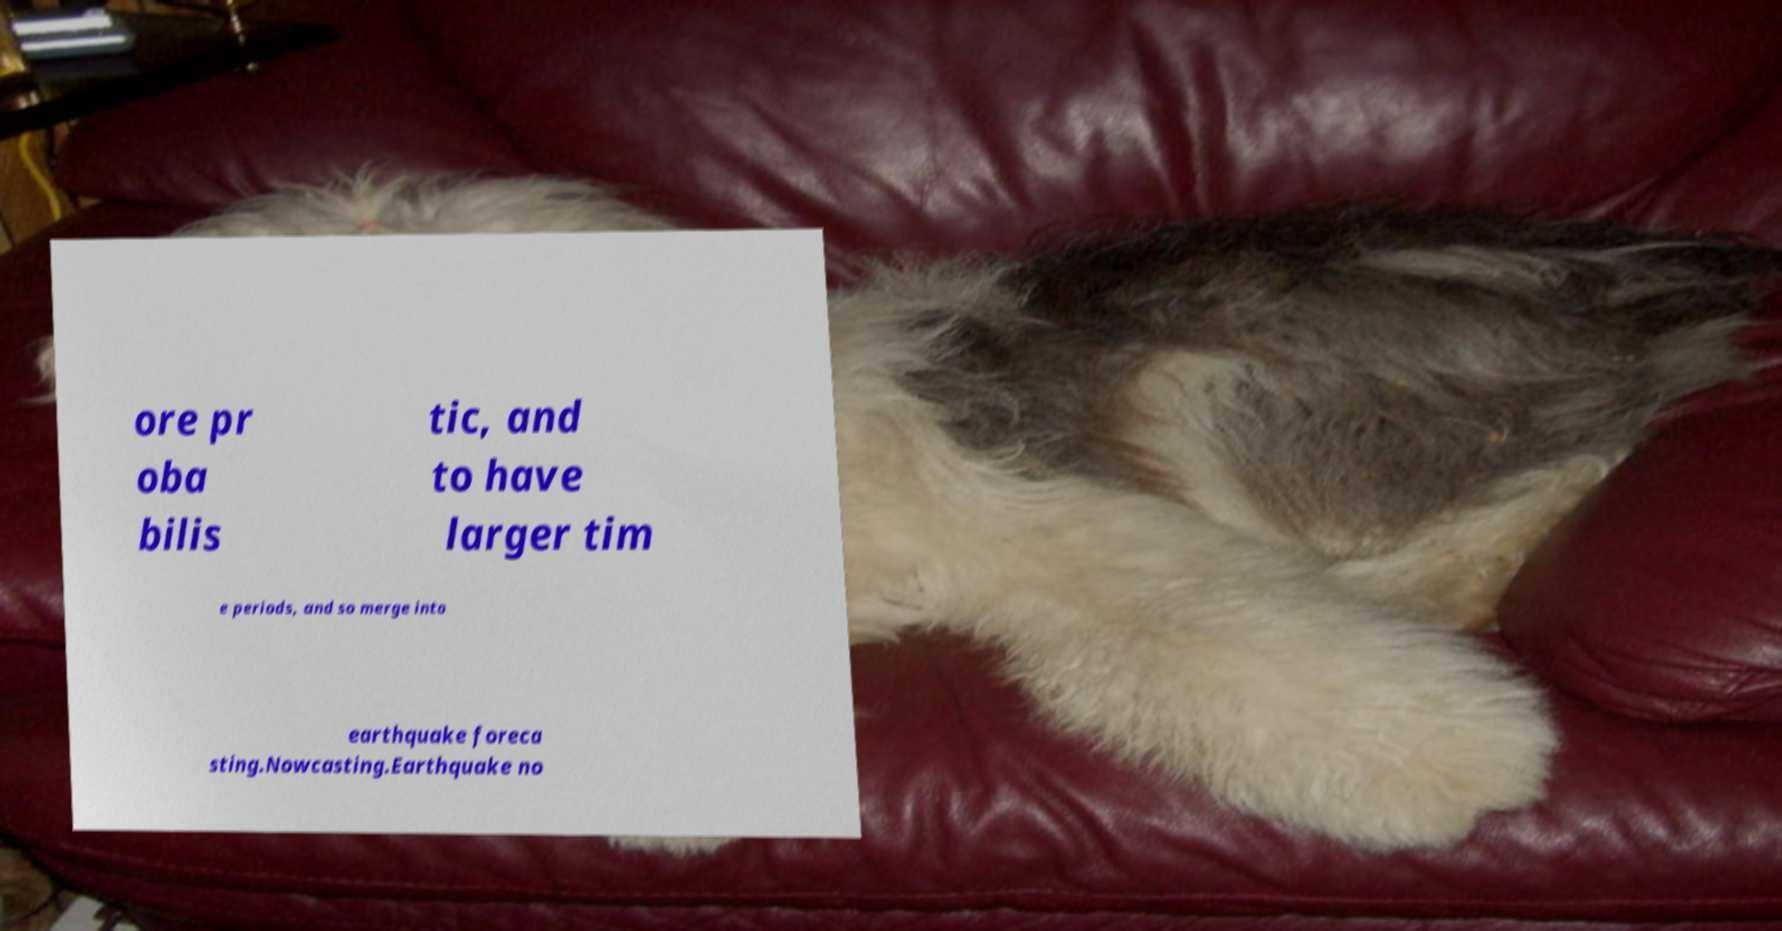Could you extract and type out the text from this image? ore pr oba bilis tic, and to have larger tim e periods, and so merge into earthquake foreca sting.Nowcasting.Earthquake no 